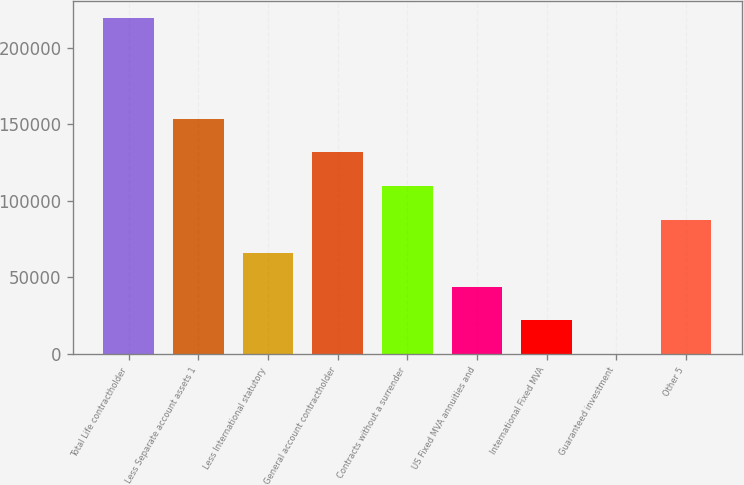<chart> <loc_0><loc_0><loc_500><loc_500><bar_chart><fcel>Total Life contractholder<fcel>Less Separate account assets 1<fcel>Less International statutory<fcel>General account contractholder<fcel>Contracts without a surrender<fcel>US Fixed MVA annuities and<fcel>International Fixed MVA<fcel>Guaranteed investment<fcel>Other 5<nl><fcel>219402<fcel>153591<fcel>65842.3<fcel>131654<fcel>109716<fcel>43905.2<fcel>21968.1<fcel>31<fcel>87779.4<nl></chart> 